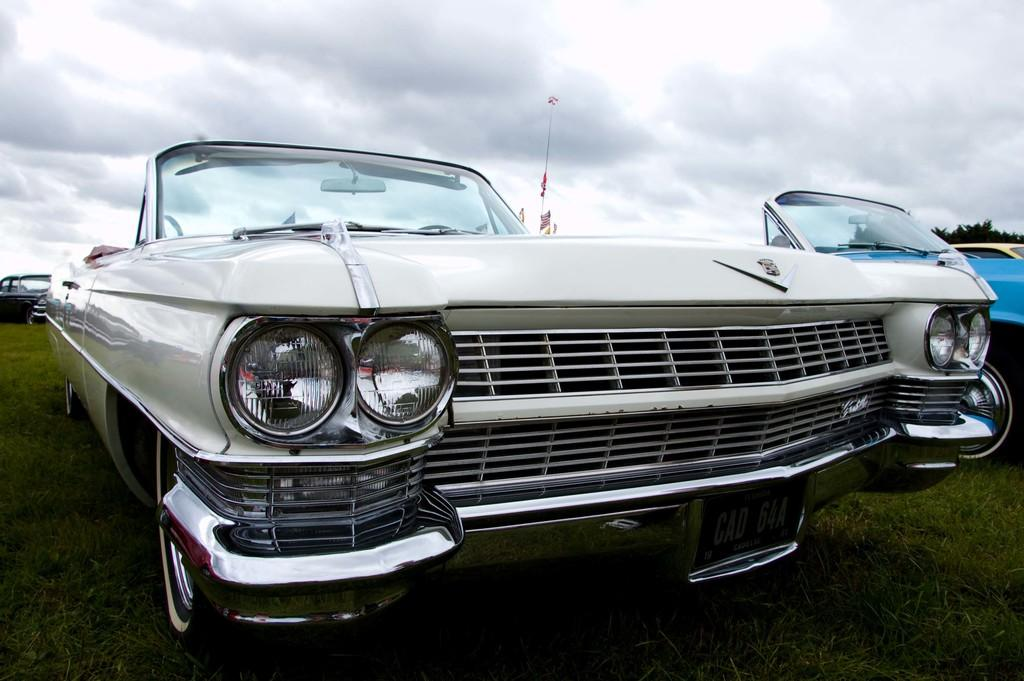What can be seen in the image? There are vehicles in the image. Where are the vehicles located? The vehicles are placed on a greenery ground. What is the condition of the sky in the image? The sky is cloudy in the image. How many hands are visible holding the bomb in the image? There is no bomb or hands present in the image; it only features vehicles on a greenery ground with a cloudy sky. 